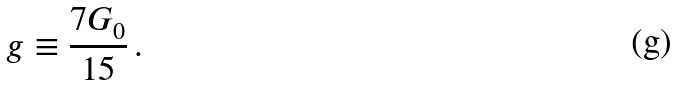Convert formula to latex. <formula><loc_0><loc_0><loc_500><loc_500>g \equiv \frac { 7 G _ { 0 } } { 1 5 } \, .</formula> 